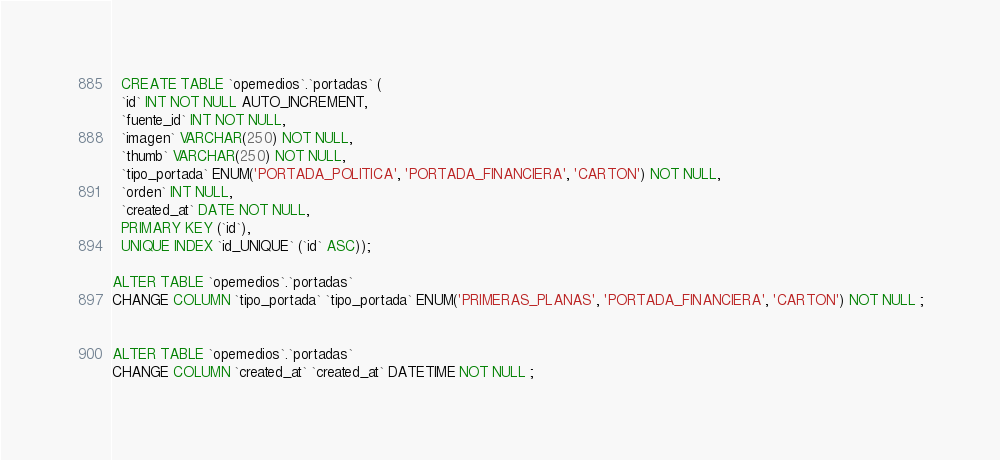<code> <loc_0><loc_0><loc_500><loc_500><_SQL_>  CREATE TABLE `opemedios`.`portadas` (
  `id` INT NOT NULL AUTO_INCREMENT,
  `fuente_id` INT NOT NULL,
  `imagen` VARCHAR(250) NOT NULL,
  `thumb` VARCHAR(250) NOT NULL,
  `tipo_portada` ENUM('PORTADA_POLITICA', 'PORTADA_FINANCIERA', 'CARTON') NOT NULL,
  `orden` INT NULL,
  `created_at` DATE NOT NULL,
  PRIMARY KEY (`id`),
  UNIQUE INDEX `id_UNIQUE` (`id` ASC));

ALTER TABLE `opemedios`.`portadas` 
CHANGE COLUMN `tipo_portada` `tipo_portada` ENUM('PRIMERAS_PLANAS', 'PORTADA_FINANCIERA', 'CARTON') NOT NULL ;


ALTER TABLE `opemedios`.`portadas` 
CHANGE COLUMN `created_at` `created_at` DATETIME NOT NULL ;
</code> 